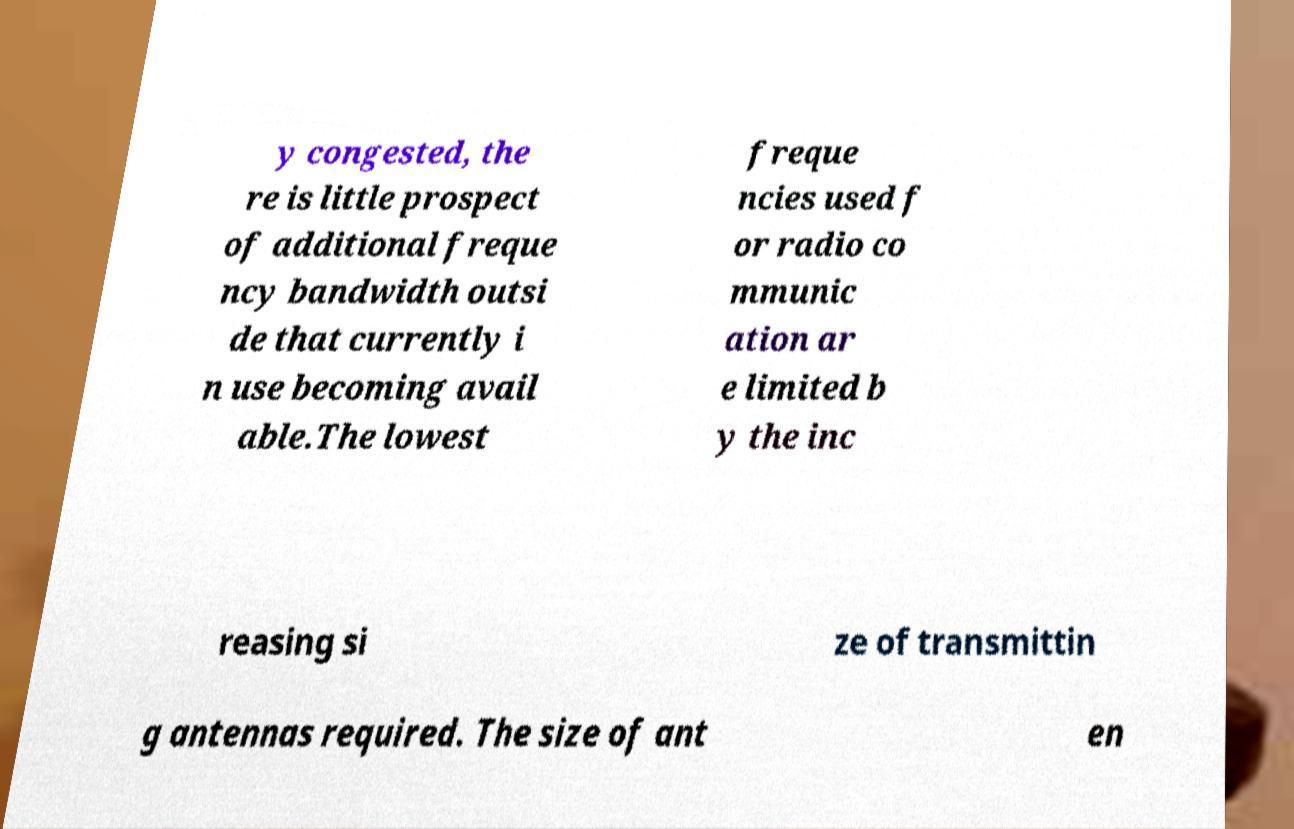Please identify and transcribe the text found in this image. y congested, the re is little prospect of additional freque ncy bandwidth outsi de that currently i n use becoming avail able.The lowest freque ncies used f or radio co mmunic ation ar e limited b y the inc reasing si ze of transmittin g antennas required. The size of ant en 